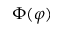Convert formula to latex. <formula><loc_0><loc_0><loc_500><loc_500>\Phi ( \varphi )</formula> 